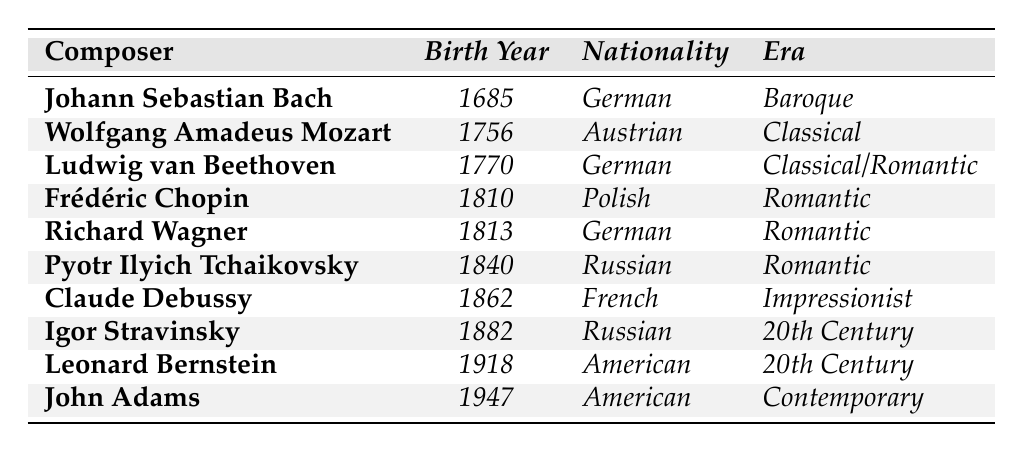What is the birth year of Ludwig van Beethoven? The table lists Ludwig van Beethoven's birth year as 1770 in the "Birth Year" column.
Answer: 1770 Which composer was born in 1813? The table shows that Richard Wagner was born in 1813 in the "Birth Year" column.
Answer: Richard Wagner How many composers were born in the Romantic era? The composers listed under the Romantic era are Frédéric Chopin, Richard Wagner, and Pyotr Ilyich Tchaikovsky, which totals three composers.
Answer: 3 Who is the only composer from the table born in the 20th century? The table indicates that both Igor Stravinsky and Leonard Bernstein were born in the 20th century; they are the only two composers listed in that era.
Answer: Igor Stravinsky and Leonard Bernstein Which composer was born the earliest, and what year was it? According to the table, Johann Sebastian Bach was born in 1685, which is the earliest year listed among all composers.
Answer: Johann Sebastian Bach, 1685 Which composer is associated with the Impressionist era? The table shows that Claude Debussy is the composer associated with the Impressionist era.
Answer: Claude Debussy Is there a composer in the table who shares the same nationality as Frédéric Chopin? The table shows that Frédéric Chopin is Polish, and the only other composer listed with the same nationality is none, as he is the only Polish composer in the table.
Answer: No What is the average birth year of the composers listed in the table? To calculate the average, we sum the birth years: 1685 + 1756 + 1770 + 1810 + 1813 + 1840 + 1862 + 1882 + 1918 + 1947 = 18483. Then, divide by the number of composers (10), which gives us an average of 1848.3.
Answer: 1848.3 Which nationality has the most composers on the table? By reviewing the nationalities, we see German contributors (Bach and Beethoven), Romantic composers (Wagner), totaling three German composers. So, German nationality has the most composers in the list.
Answer: German Is Johann Sebastian Bach the only Baroque composer listed? Yes, the table states that Johann Sebastian Bach is the only composer categorized under the Baroque era.
Answer: Yes 